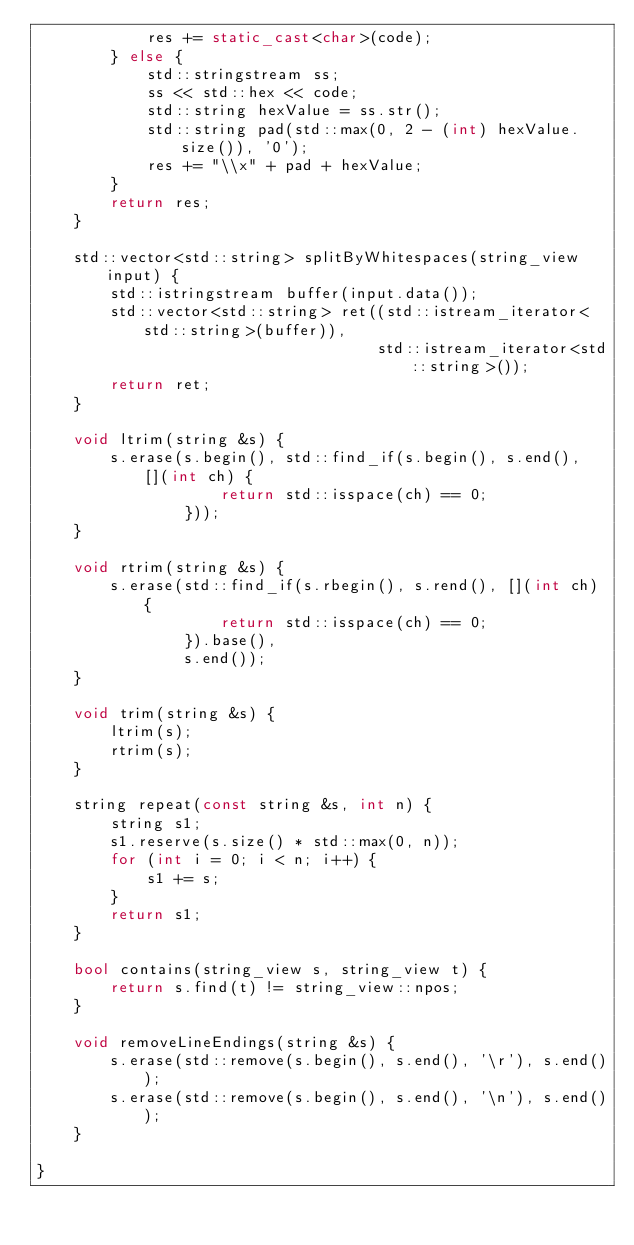Convert code to text. <code><loc_0><loc_0><loc_500><loc_500><_C++_>            res += static_cast<char>(code);
        } else {
            std::stringstream ss;
            ss << std::hex << code;
            std::string hexValue = ss.str();
            std::string pad(std::max(0, 2 - (int) hexValue.size()), '0');
            res += "\\x" + pad + hexValue;
        }
        return res;
    }

    std::vector<std::string> splitByWhitespaces(string_view input) {
        std::istringstream buffer(input.data());
        std::vector<std::string> ret((std::istream_iterator<std::string>(buffer)),
                                     std::istream_iterator<std::string>());
        return ret;
    }

    void ltrim(string &s) {
        s.erase(s.begin(), std::find_if(s.begin(), s.end(), [](int ch) {
                    return std::isspace(ch) == 0;
                }));
    }

    void rtrim(string &s) {
        s.erase(std::find_if(s.rbegin(), s.rend(), [](int ch) {
                    return std::isspace(ch) == 0;
                }).base(),
                s.end());
    }

    void trim(string &s) {
        ltrim(s);
        rtrim(s);
    }

    string repeat(const string &s, int n) {
        string s1;
        s1.reserve(s.size() * std::max(0, n));
        for (int i = 0; i < n; i++) {
            s1 += s;
        }
        return s1;
    }

    bool contains(string_view s, string_view t) {
        return s.find(t) != string_view::npos;
    }

    void removeLineEndings(string &s) {
        s.erase(std::remove(s.begin(), s.end(), '\r'), s.end());
        s.erase(std::remove(s.begin(), s.end(), '\n'), s.end());
    }

}</code> 